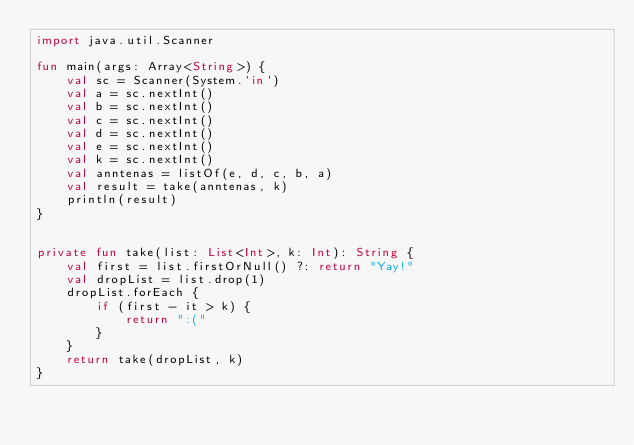Convert code to text. <code><loc_0><loc_0><loc_500><loc_500><_Kotlin_>import java.util.Scanner

fun main(args: Array<String>) {
    val sc = Scanner(System.`in`)
    val a = sc.nextInt()
    val b = sc.nextInt()
    val c = sc.nextInt()
    val d = sc.nextInt()
    val e = sc.nextInt()
    val k = sc.nextInt()
    val anntenas = listOf(e, d, c, b, a)
    val result = take(anntenas, k)
    println(result)
}


private fun take(list: List<Int>, k: Int): String {
    val first = list.firstOrNull() ?: return "Yay!"
    val dropList = list.drop(1)
    dropList.forEach {
        if (first - it > k) {
            return ":("
        }
    }
    return take(dropList, k)
}</code> 